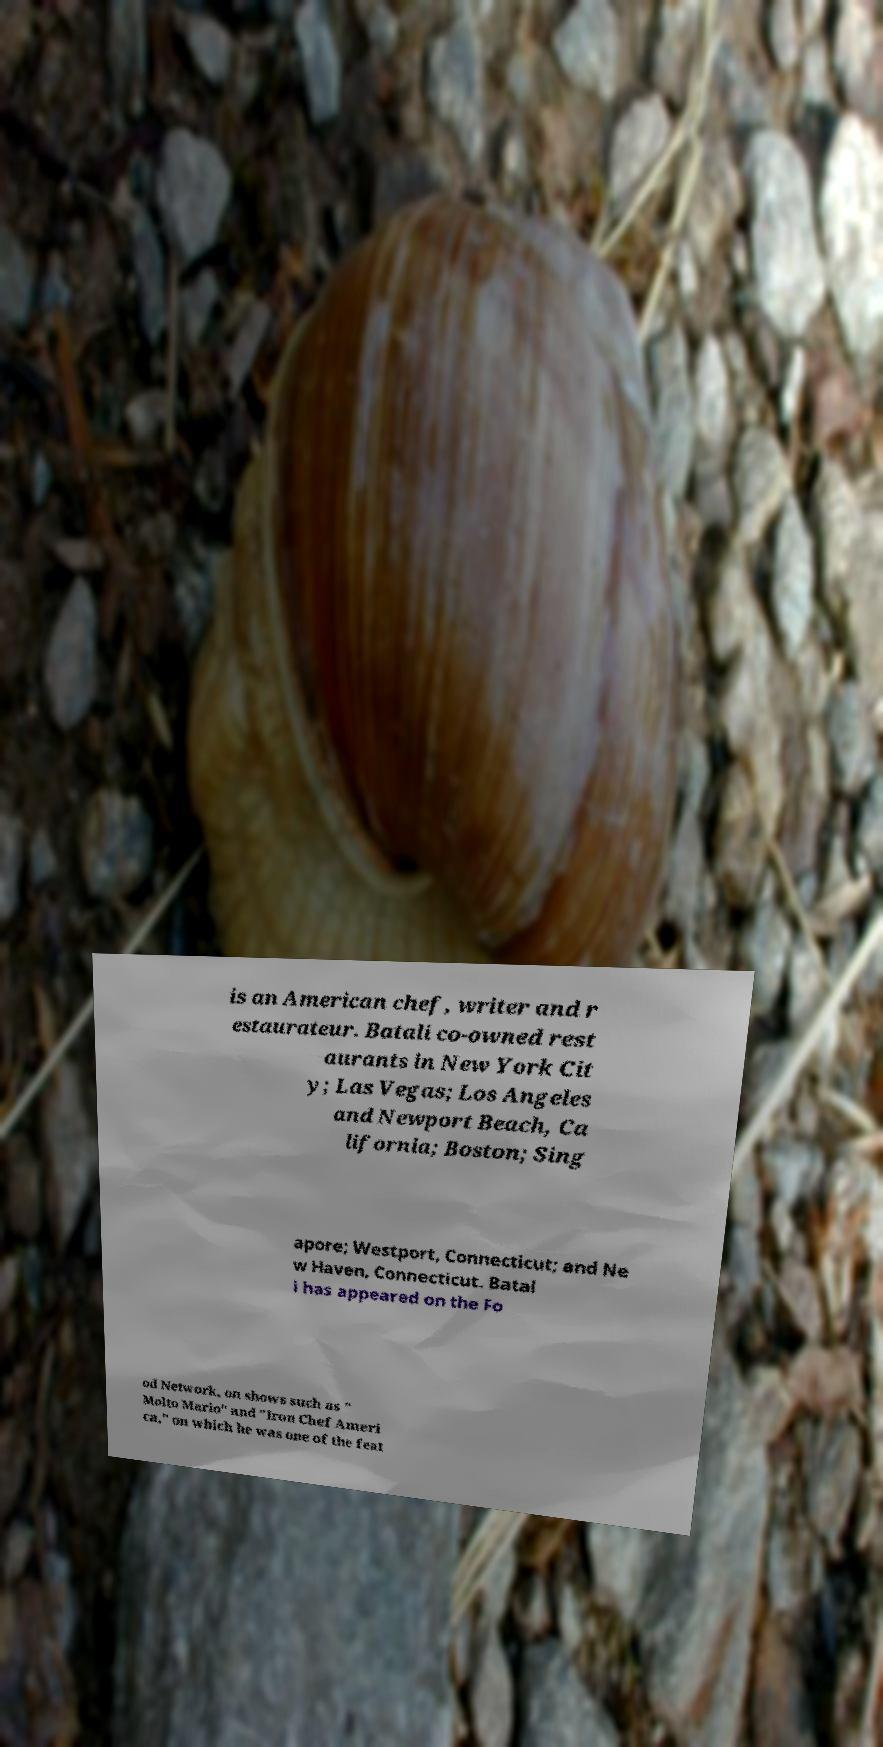I need the written content from this picture converted into text. Can you do that? is an American chef, writer and r estaurateur. Batali co-owned rest aurants in New York Cit y; Las Vegas; Los Angeles and Newport Beach, Ca lifornia; Boston; Sing apore; Westport, Connecticut; and Ne w Haven, Connecticut. Batal i has appeared on the Fo od Network, on shows such as " Molto Mario" and "Iron Chef Ameri ca," on which he was one of the feat 